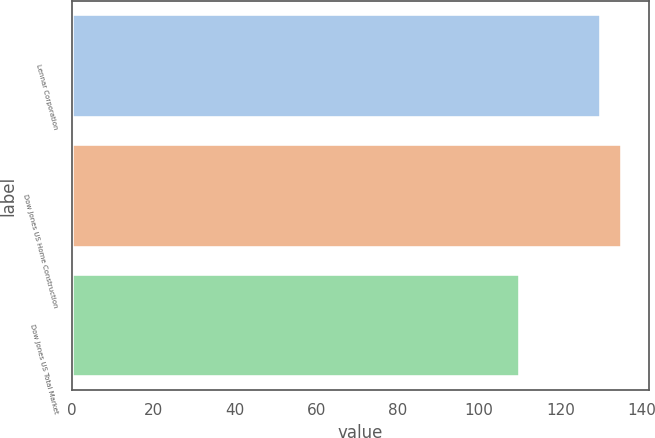Convert chart. <chart><loc_0><loc_0><loc_500><loc_500><bar_chart><fcel>Lennar Corporation<fcel>Dow Jones US Home Construction<fcel>Dow Jones US Total Market<nl><fcel>130<fcel>135<fcel>110<nl></chart> 